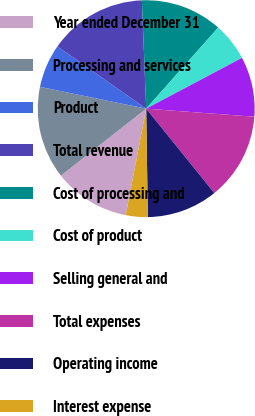Convert chart to OTSL. <chart><loc_0><loc_0><loc_500><loc_500><pie_chart><fcel>Year ended December 31<fcel>Processing and services<fcel>Product<fcel>Total revenue<fcel>Cost of processing and<fcel>Cost of product<fcel>Selling general and<fcel>Total expenses<fcel>Operating income<fcel>Interest expense<nl><fcel>11.38%<fcel>13.82%<fcel>6.51%<fcel>14.63%<fcel>12.19%<fcel>5.69%<fcel>8.94%<fcel>13.01%<fcel>10.57%<fcel>3.26%<nl></chart> 